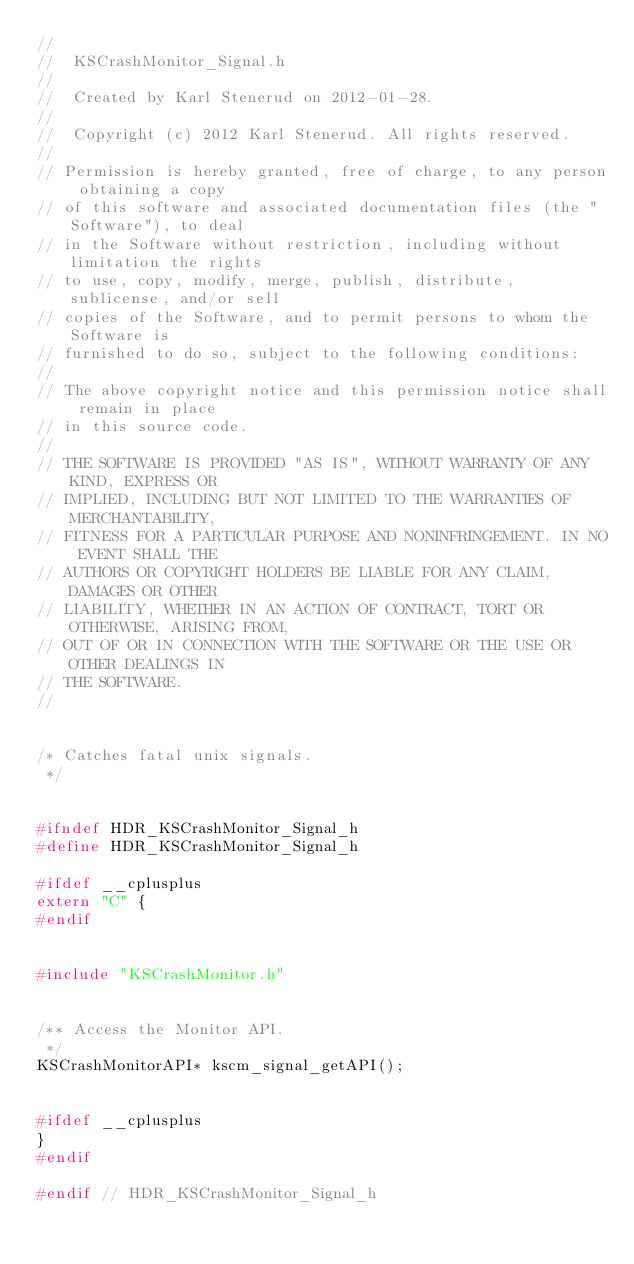Convert code to text. <code><loc_0><loc_0><loc_500><loc_500><_C_>//
//  KSCrashMonitor_Signal.h
//
//  Created by Karl Stenerud on 2012-01-28.
//
//  Copyright (c) 2012 Karl Stenerud. All rights reserved.
//
// Permission is hereby granted, free of charge, to any person obtaining a copy
// of this software and associated documentation files (the "Software"), to deal
// in the Software without restriction, including without limitation the rights
// to use, copy, modify, merge, publish, distribute, sublicense, and/or sell
// copies of the Software, and to permit persons to whom the Software is
// furnished to do so, subject to the following conditions:
//
// The above copyright notice and this permission notice shall remain in place
// in this source code.
//
// THE SOFTWARE IS PROVIDED "AS IS", WITHOUT WARRANTY OF ANY KIND, EXPRESS OR
// IMPLIED, INCLUDING BUT NOT LIMITED TO THE WARRANTIES OF MERCHANTABILITY,
// FITNESS FOR A PARTICULAR PURPOSE AND NONINFRINGEMENT. IN NO EVENT SHALL THE
// AUTHORS OR COPYRIGHT HOLDERS BE LIABLE FOR ANY CLAIM, DAMAGES OR OTHER
// LIABILITY, WHETHER IN AN ACTION OF CONTRACT, TORT OR OTHERWISE, ARISING FROM,
// OUT OF OR IN CONNECTION WITH THE SOFTWARE OR THE USE OR OTHER DEALINGS IN
// THE SOFTWARE.
//


/* Catches fatal unix signals.
 */


#ifndef HDR_KSCrashMonitor_Signal_h
#define HDR_KSCrashMonitor_Signal_h

#ifdef __cplusplus
extern "C" {
#endif


#include "KSCrashMonitor.h"


/** Access the Monitor API.
 */
KSCrashMonitorAPI* kscm_signal_getAPI();


#ifdef __cplusplus
}
#endif

#endif // HDR_KSCrashMonitor_Signal_h
</code> 